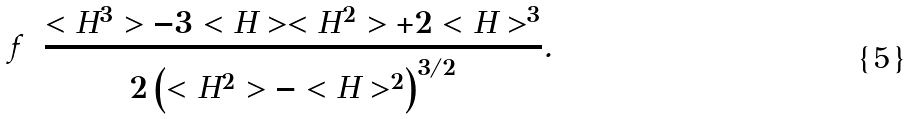<formula> <loc_0><loc_0><loc_500><loc_500>f = \frac { < H ^ { 3 } > - 3 < H > < H ^ { 2 } > + 2 < H > ^ { 3 } } { 2 \left ( < H ^ { 2 } > - < H > ^ { 2 } \right ) ^ { 3 / 2 } } .</formula> 